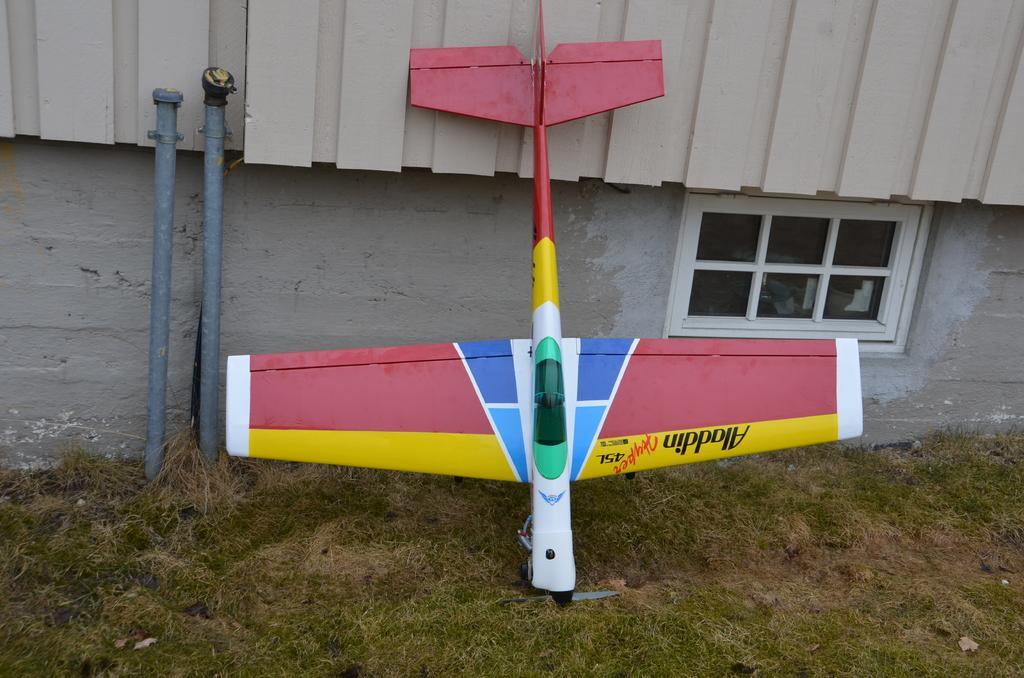Please provide a concise description of this image. Here I can see a toy plane. At the bottom I can see the grass. On the left side there are two poles. In the background there is a wall along with the window. At the top there is a metal object. 